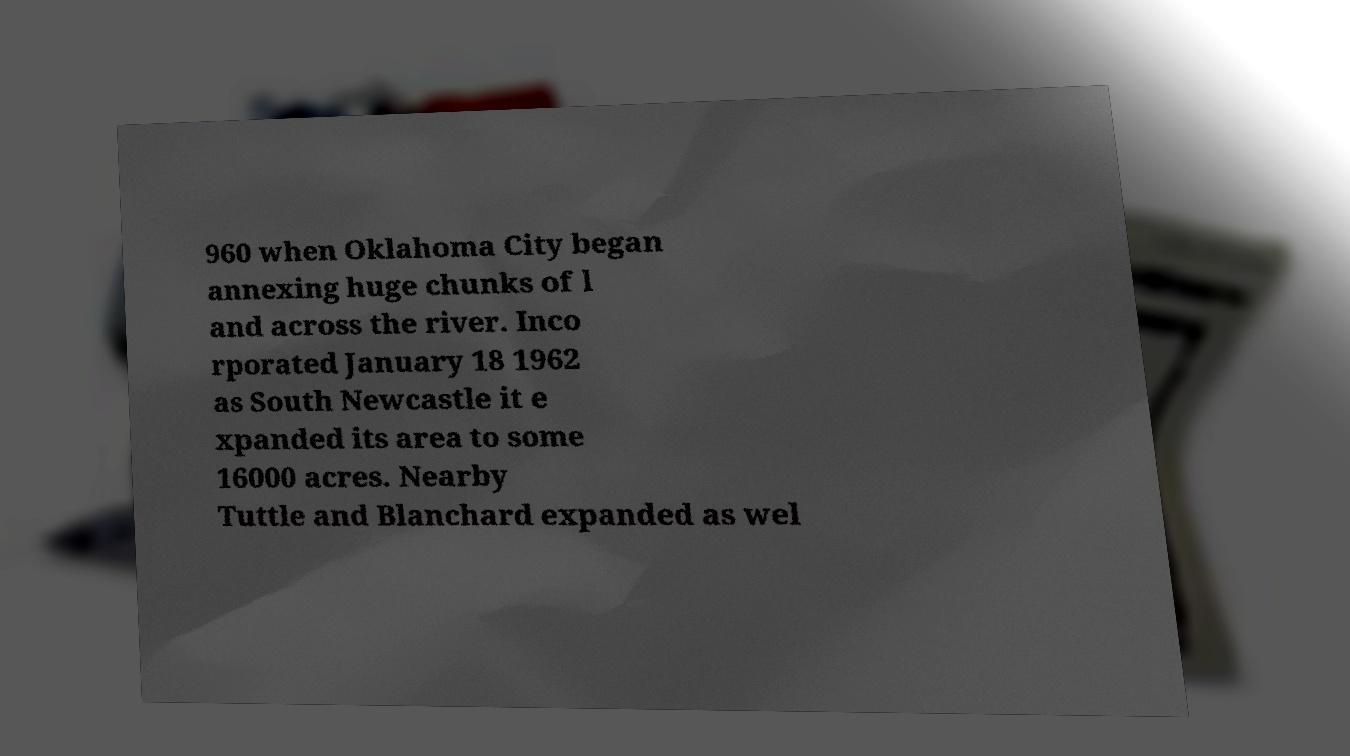There's text embedded in this image that I need extracted. Can you transcribe it verbatim? 960 when Oklahoma City began annexing huge chunks of l and across the river. Inco rporated January 18 1962 as South Newcastle it e xpanded its area to some 16000 acres. Nearby Tuttle and Blanchard expanded as wel 